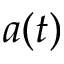<formula> <loc_0><loc_0><loc_500><loc_500>a ( t )</formula> 